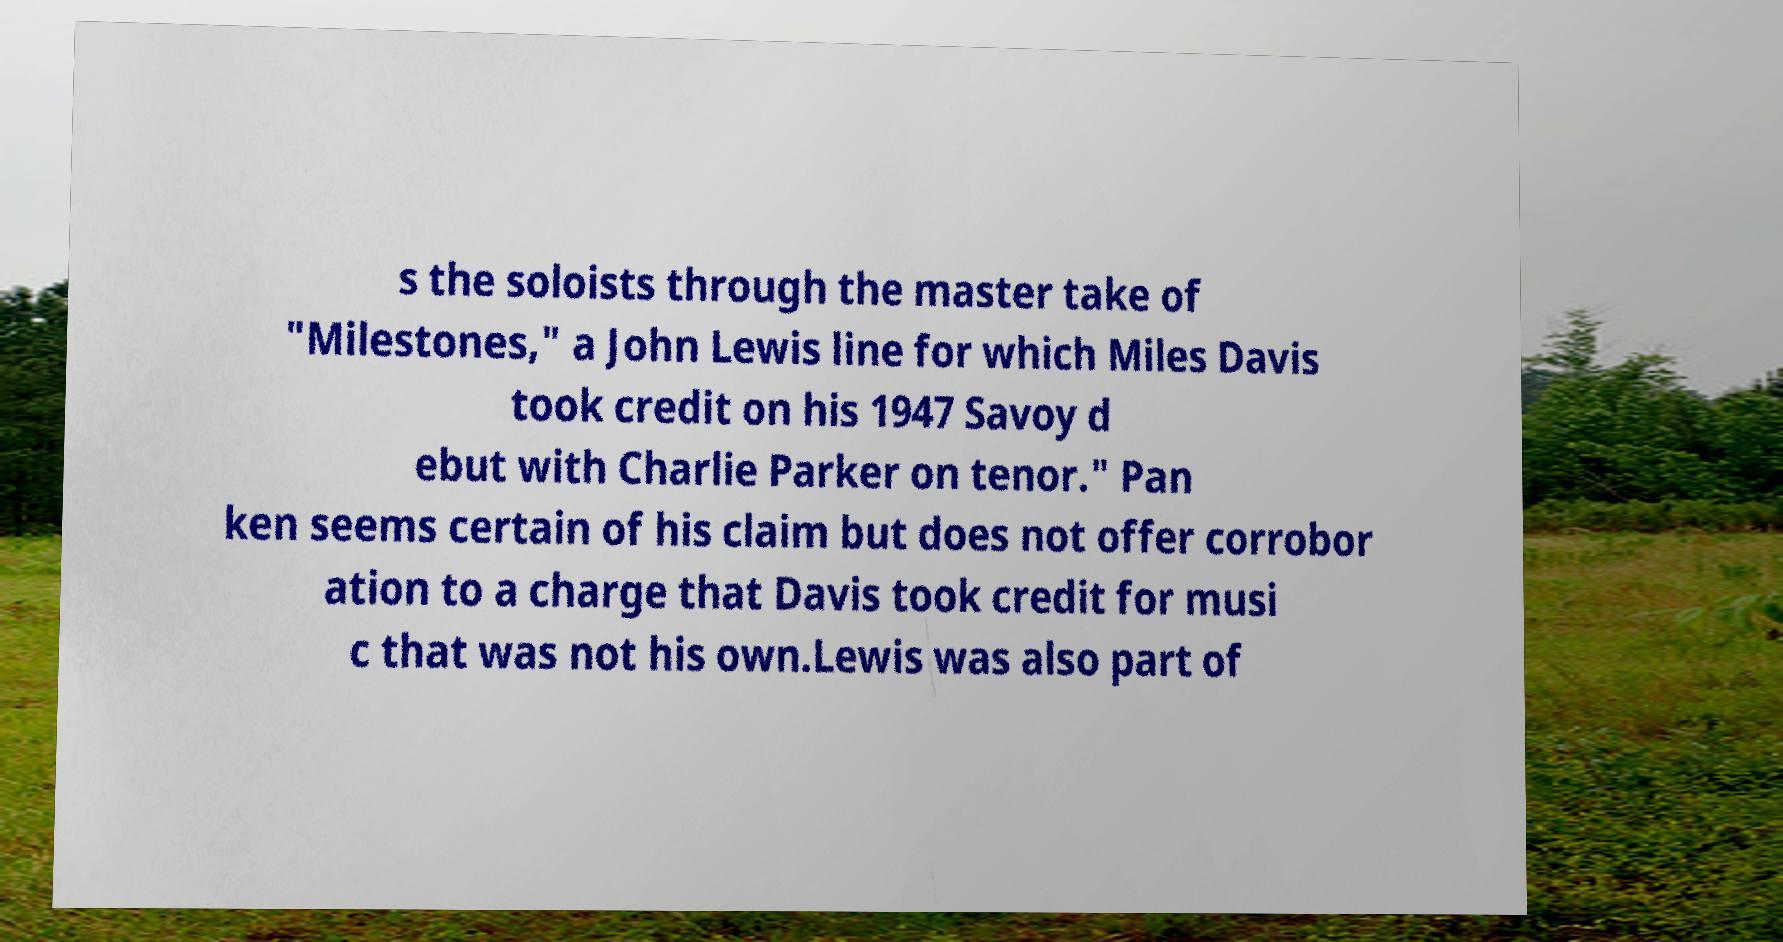Can you read and provide the text displayed in the image?This photo seems to have some interesting text. Can you extract and type it out for me? s the soloists through the master take of "Milestones," a John Lewis line for which Miles Davis took credit on his 1947 Savoy d ebut with Charlie Parker on tenor." Pan ken seems certain of his claim but does not offer corrobor ation to a charge that Davis took credit for musi c that was not his own.Lewis was also part of 